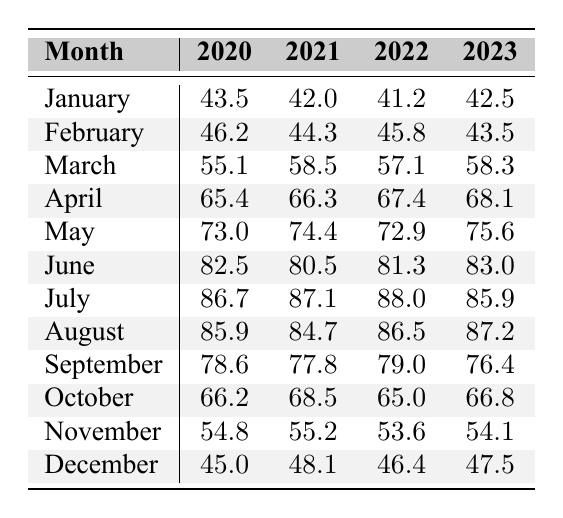What was the average temperature in Dallas for July 2022? In July 2022, the average temperature is clearly stated in the table as 88.0 degrees.
Answer: 88.0 Which month had the highest average temperature in 2020? By looking at the 2020 column, July has the highest temperature at 86.7 degrees.
Answer: July If I compare the temperature of May in 2021 and 2022, which May was warmer? In May 2021, the temperature is 74.4 degrees, while in May 2022, it's 72.9 degrees. Since 74.4 > 72.9, May 2021 was warmer.
Answer: May 2021 What are the average temperatures for October from 2020 to 2023? The temperatures for October are 66.2 (2020), 68.5 (2021), 65.0 (2022), and 66.8 (2023).
Answer: 66.2, 68.5, 65.0, 66.8 Which year had the lowest average temperature in January? Checking the January temperatures: 43.5 (2020), 42.0 (2021), 41.2 (2022), and 42.5 (2023), we find that 2022 had the lowest temperature at 41.2 degrees.
Answer: 2022 In 2023, how does the February temperature compare to both 2020 and 2021? February 2023 was 43.5 degrees, which is lower than 46.2 (2020) and 44.3 (2021), indicating that February 2023 was cooler than both previous years.
Answer: Cooler What is the overall trend in temperature from January to December in 2022? For 2022, the January temperature is 41.2, increasing steadily to 88.0 in July, then decreasing to 46.4 in December. This shows a general rise in temperature until mid-year followed by a drop.
Answer: Increased then decreased Which month had a temperature drop from 2021 to 2022 and what was the temperature change for that month? November saw a decrease from 55.2 (2021) to 53.6 (2022), which represents a drop of 1.6 degrees.
Answer: November, 1.6 degrees drop What is the average temperature for the month of June across the four years? The June temperatures are 82.5 (2020), 80.5 (2021), 81.3 (2022), and 83.0 (2023). First, sum these temperatures: 82.5 + 80.5 + 81.3 + 83.0 = 327.3. Then divide by 4 for the average: 327.3 / 4 = 81.825, approximately 81.8 degrees.
Answer: 81.8 Is it true that the average temperature for April increased every year from 2020 to 2023? The temperatures are 65.4 (2020), 66.3 (2021), 67.4 (2022), and 68.1 (2023). Each year shows an increase, confirming the statement is true.
Answer: Yes Which month in 2021 had a temperature that was closer to 80 degrees - June or July? June 2021 had 80.5 degrees, while July had 87.1 degrees. The difference from 80 is smaller for June (0.5 degrees) than for July (7.1 degrees). Hence, June is closer to 80 degrees.
Answer: June 